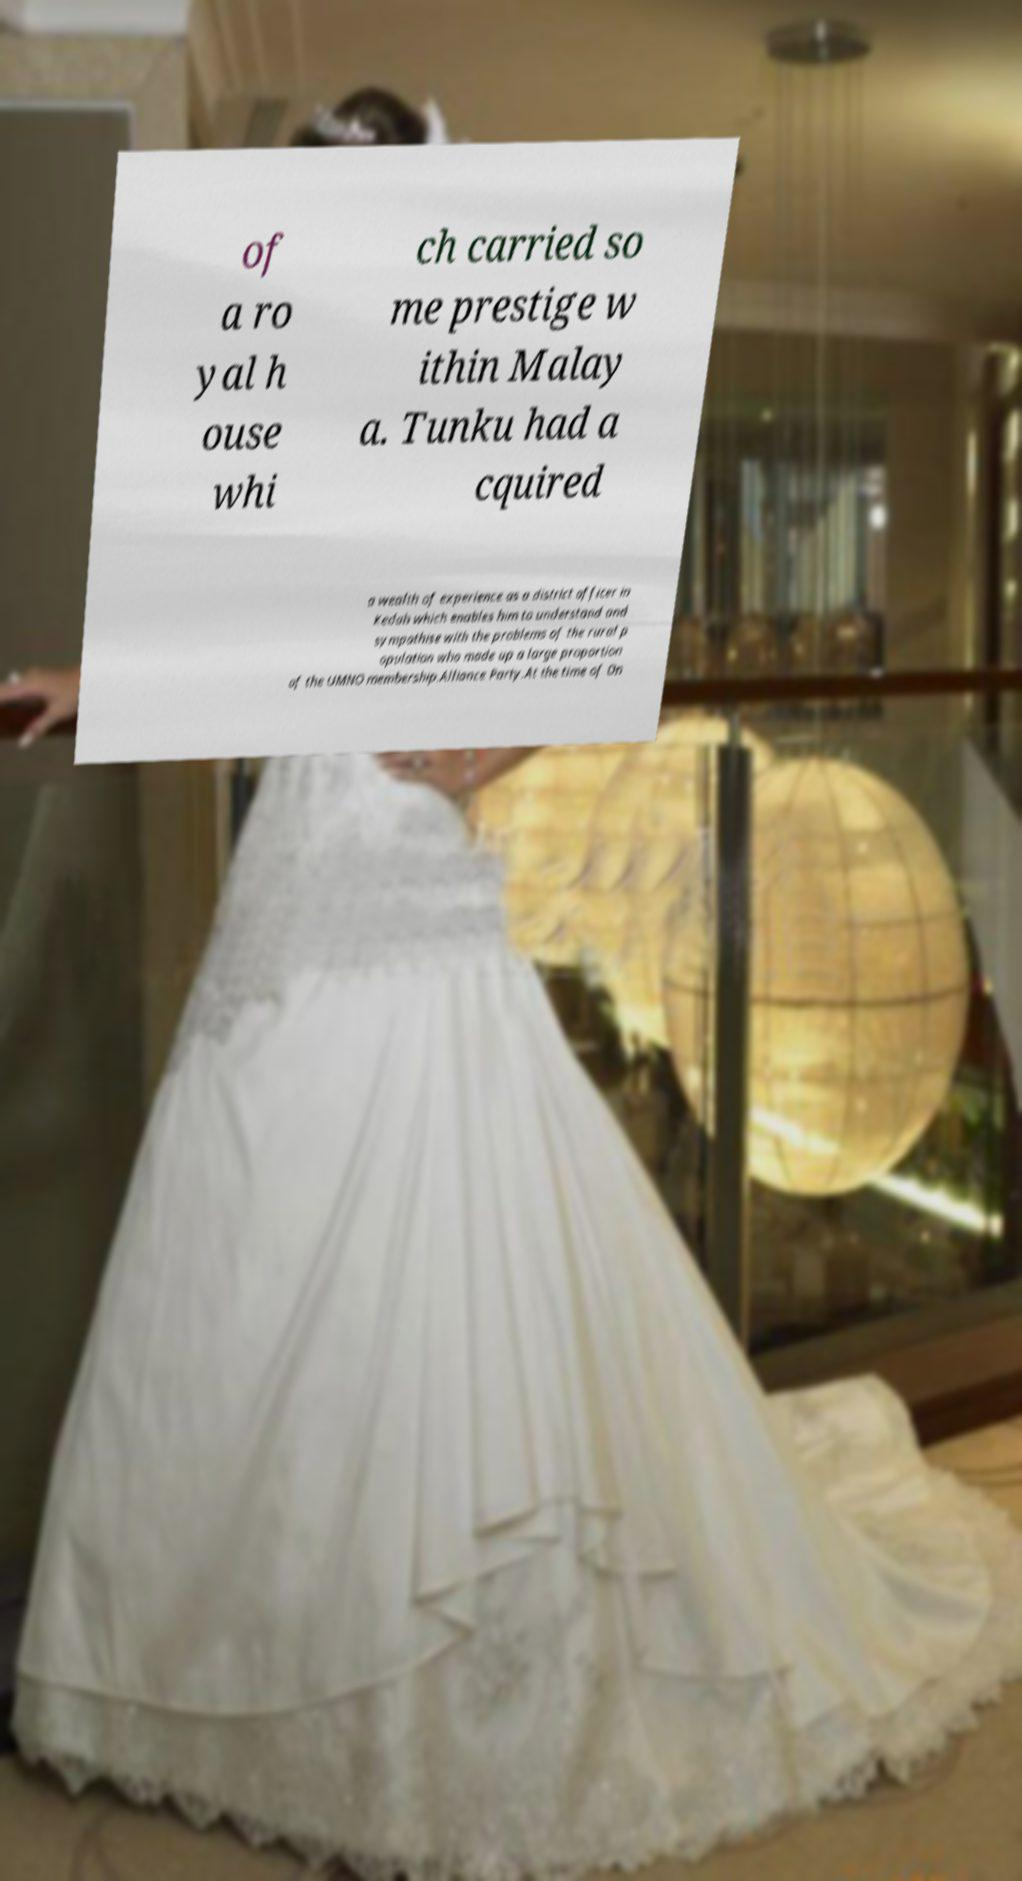Can you accurately transcribe the text from the provided image for me? of a ro yal h ouse whi ch carried so me prestige w ithin Malay a. Tunku had a cquired a wealth of experience as a district officer in Kedah which enables him to understand and sympathise with the problems of the rural p opulation who made up a large proportion of the UMNO membership.Alliance Party.At the time of On 